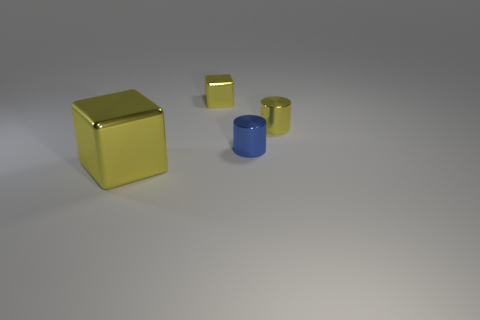How does the lighting in the image affect the appearance of the objects? The lighting in the image creates soft shadows and highlights on the objects, enhancing their three-dimensional form and the reflective quality of their surfaces. The gentle gradient across the ground suggests a diffuse light source. Could the lighting indicate a specific time of day or environment setting? The controlled lighting and lack of environmental clues make it difficult to determine a specific time of day or setting. This appears to be a staged scene, perhaps in a studio setup designed to emphasize the objects’ features without external context. 